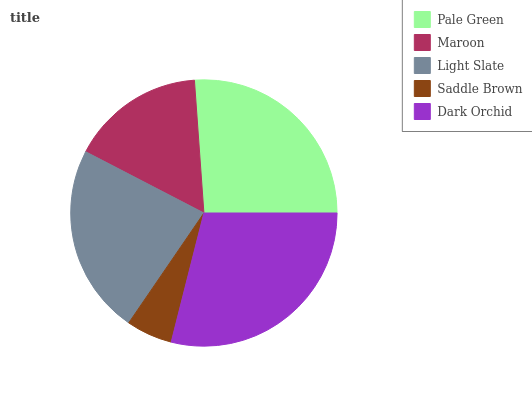Is Saddle Brown the minimum?
Answer yes or no. Yes. Is Dark Orchid the maximum?
Answer yes or no. Yes. Is Maroon the minimum?
Answer yes or no. No. Is Maroon the maximum?
Answer yes or no. No. Is Pale Green greater than Maroon?
Answer yes or no. Yes. Is Maroon less than Pale Green?
Answer yes or no. Yes. Is Maroon greater than Pale Green?
Answer yes or no. No. Is Pale Green less than Maroon?
Answer yes or no. No. Is Light Slate the high median?
Answer yes or no. Yes. Is Light Slate the low median?
Answer yes or no. Yes. Is Saddle Brown the high median?
Answer yes or no. No. Is Pale Green the low median?
Answer yes or no. No. 